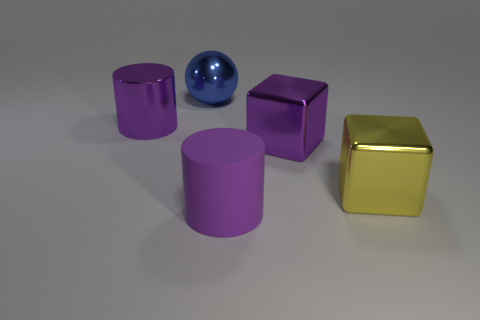Subtract 1 cylinders. How many cylinders are left? 1 Subtract all purple cubes. How many cubes are left? 1 Subtract all red blocks. Subtract all brown cylinders. How many blocks are left? 2 Subtract all gray cylinders. How many yellow blocks are left? 1 Subtract all blue spheres. Subtract all shiny balls. How many objects are left? 3 Add 4 blue balls. How many blue balls are left? 5 Add 4 big spheres. How many big spheres exist? 5 Add 5 large purple cylinders. How many objects exist? 10 Subtract 0 cyan blocks. How many objects are left? 5 Subtract all spheres. How many objects are left? 4 